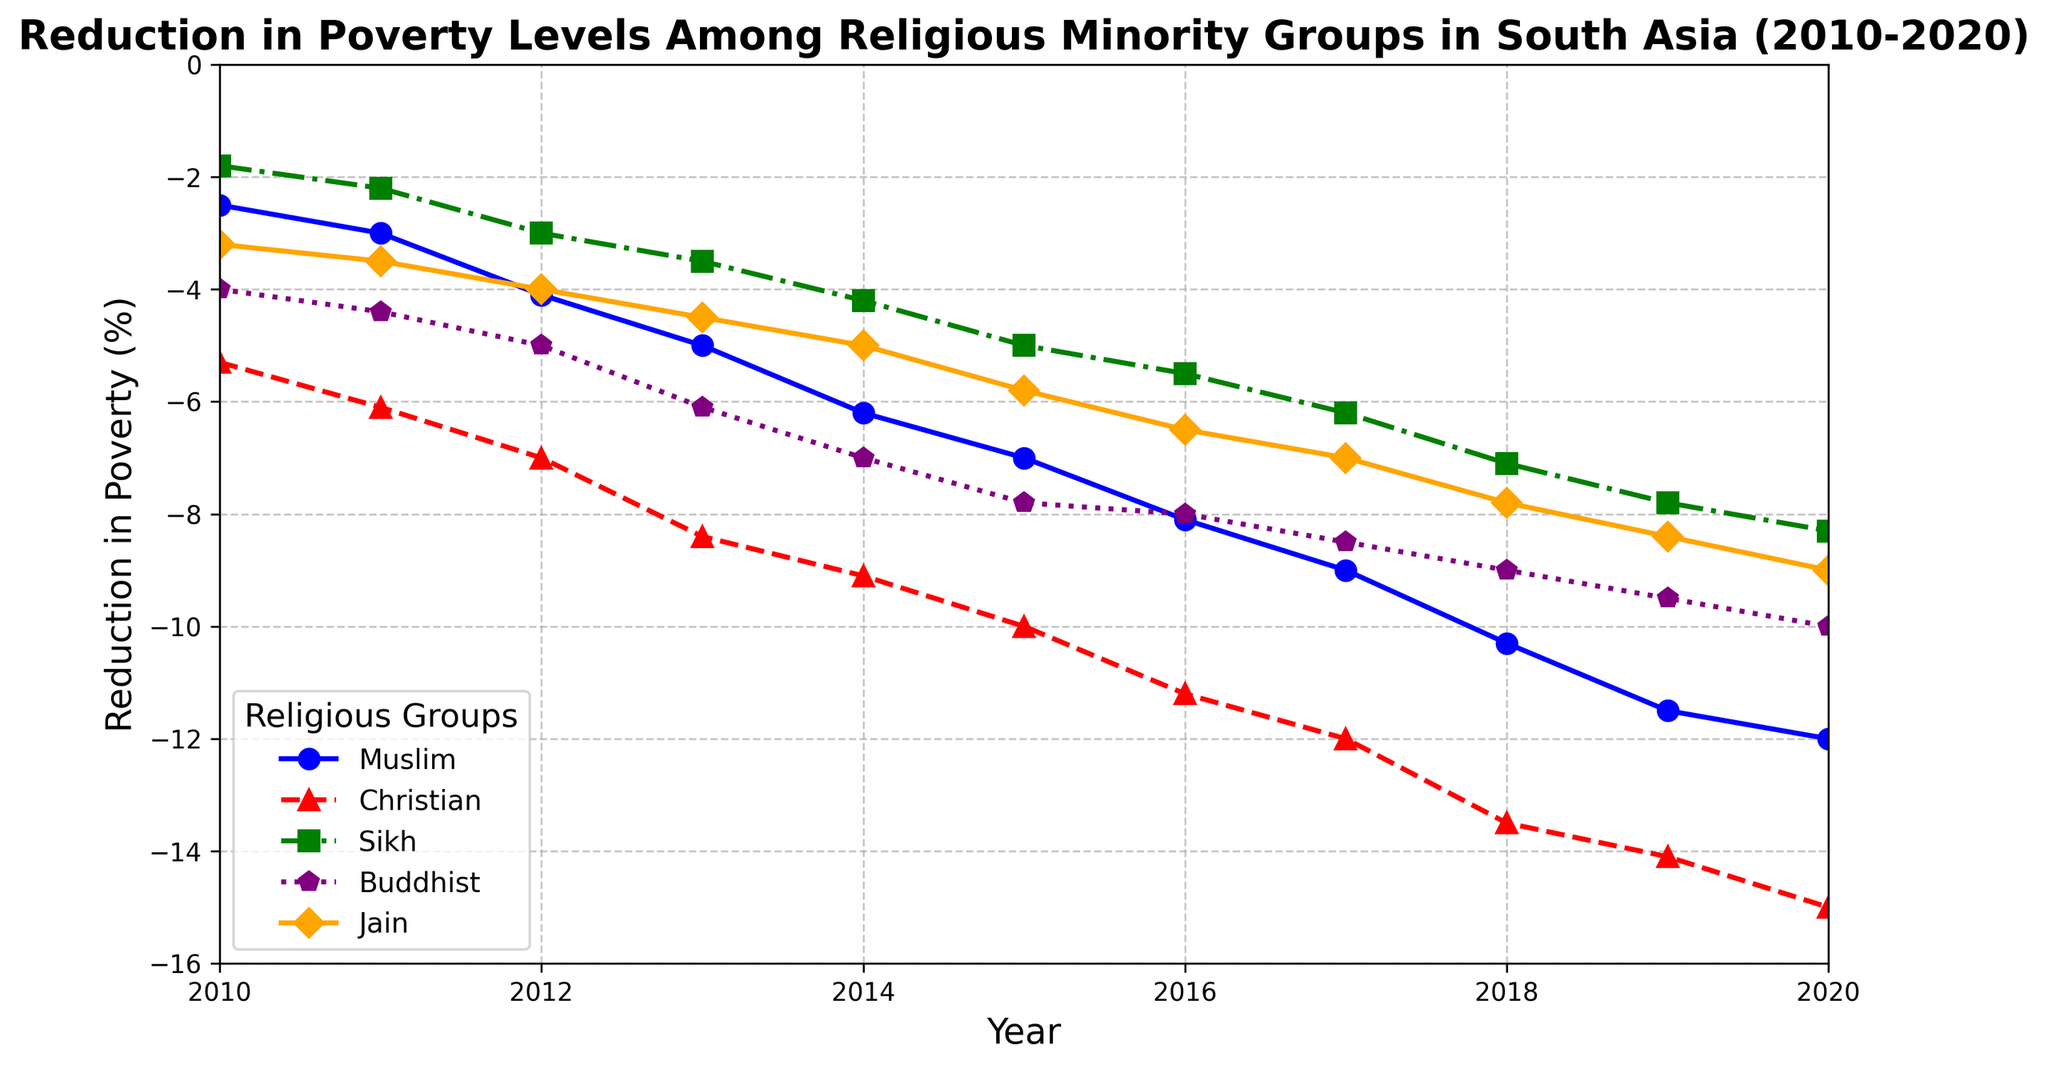Which religious minority group showed the largest reduction in poverty levels by 2020? According to the figure, the Christian group showed the largest reduction in poverty levels by 2020, reaching -15.0%. This is depicted by the red line with the label "Christian" at the bottom.
Answer: Christian Between which years did the poverty level reduction for the Buddhist group show the most significant drop? By examining the slope of the purple line representing the Buddhist group, the most significant drop appears between 2011 and 2012, where it went from -4.4% to -5.0%, a reduction of 0.6%.
Answer: 2011-2012 Which group had a reduction in poverty levels that reached below -10% first? The red line representing the Christian group reached below -10% first in the year 2015 with a value of -10.0%.
Answer: Christian What is the average reduction in poverty levels for the Sikh group between 2010 and 2020? Sum the reductions from 2010 to 2020 for the Sikh group (-1.8, -2.2, -3.0, -3.5, -4.2, -5.0, -5.5, -6.2, -7.1, -7.8, -8.3). The total is -54.6. Dividing by 11 years, the average reduction is ~-4.96%.
Answer: -4.96% Which two groups had the closest reduction in poverty levels in 2018? In 2018, the reductions for Jain (-7.8%) and Buddhist (-9.0%) groups are closest compared to the other groups, with a difference of 1.2%.
Answer: Jain and Buddhist How did the reduction in poverty levels for the Muslim group compare from 2010 to 2015? The Muslim group's reduction increased from -2.5% in 2010 to -7.0% in 2015. The difference is -7.0% - (-2.5%) = -4.5%.
Answer: -4.5% What is the difference in the reduction of poverty levels between the Christian and Jain groups in 2020? In 2020, the reduction in poverty for the Christian group is -15.0%, and for the Jain group is -9.0%. The difference is -15.0% - (-9.0%) = -6.0%.
Answer: -6.0% Is there any year when Sikh and Buddhist groups had the same reduction in poverty levels? No, looking across the years, the reduction in poverty levels for Sikh and Buddhist groups has different values each year.
Answer: No What was the reduction in poverty levels for all the groups combined in 2016? The reductions for 2016 are Muslim: -8.1%, Christian: -11.2%, Sikh: -5.5%, Buddhist: -8.0%, Jain: -6.5%. Sum these values: -8.1 + -11.2 + -5.5 + -8.0 + -6.5 = -39.3%.
Answer: -39.3% Which religious group had a consistently slower reduction each year compared to the other groups? The Sikh group, represented by the green line, shows a consistently slower reduction each year compared to the other groups.
Answer: Sikh 